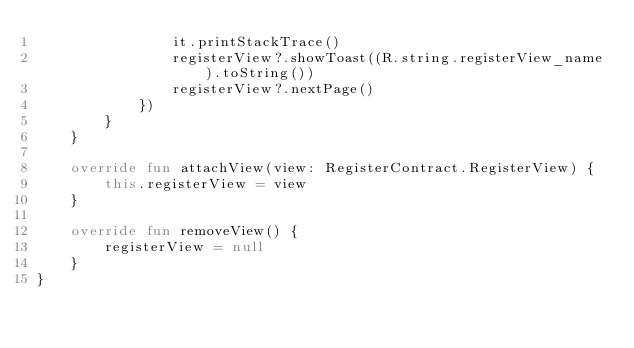Convert code to text. <code><loc_0><loc_0><loc_500><loc_500><_Kotlin_>                it.printStackTrace()
                registerView?.showToast((R.string.registerView_name).toString())
                registerView?.nextPage()
            })
        }
    }

    override fun attachView(view: RegisterContract.RegisterView) {
        this.registerView = view
    }

    override fun removeView() {
        registerView = null
    }
}</code> 